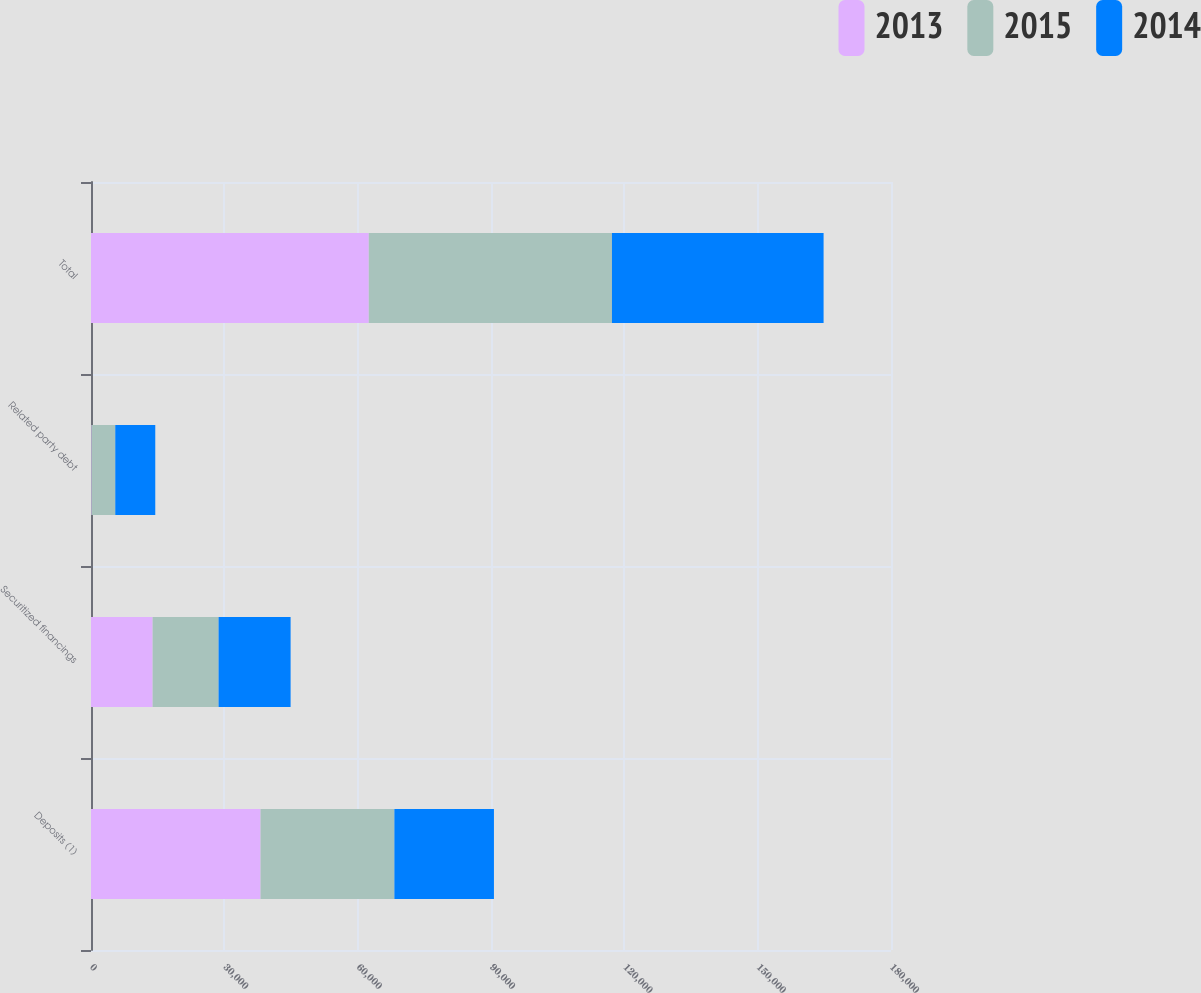Convert chart. <chart><loc_0><loc_0><loc_500><loc_500><stacked_bar_chart><ecel><fcel>Deposits (1)<fcel>Securitized financings<fcel>Related party debt<fcel>Total<nl><fcel>2013<fcel>38148<fcel>13868<fcel>125<fcel>62500<nl><fcel>2015<fcel>30110<fcel>14835<fcel>5335<fcel>54718<nl><fcel>2014<fcel>22405<fcel>16209<fcel>9000<fcel>47614<nl></chart> 